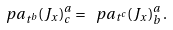Convert formula to latex. <formula><loc_0><loc_0><loc_500><loc_500>\ p a _ { t ^ { b } } ( J _ { x } ) ^ { a } _ { c } = \ p a _ { t ^ { c } } ( J _ { x } ) ^ { a } _ { b } \, .</formula> 